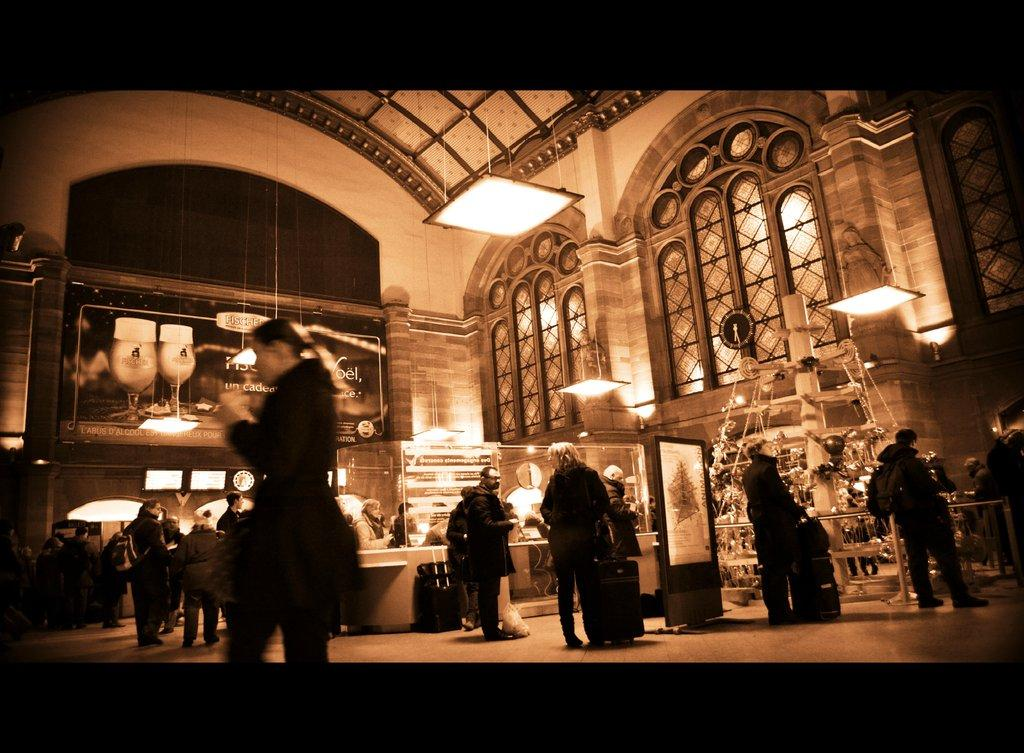How many people are in the image? There is a group of people in the image, but the exact number cannot be determined from the provided facts. What objects are associated with travel in the image? There are suitcases in the image, which are commonly used for travel. What type of structures are present in the image? There are boards and a building in the image. What can be used for illumination in the image? There are lights in the image. What type of windows are present in the building? There are glass windows in the image. What type of oven is visible in the image? There is no oven present in the image. What type of voyage are the people in the image embarking on? The provided facts do not give any information about the people's plans or intentions, so it is impossible to determine the type of voyage they might be embarking on. 